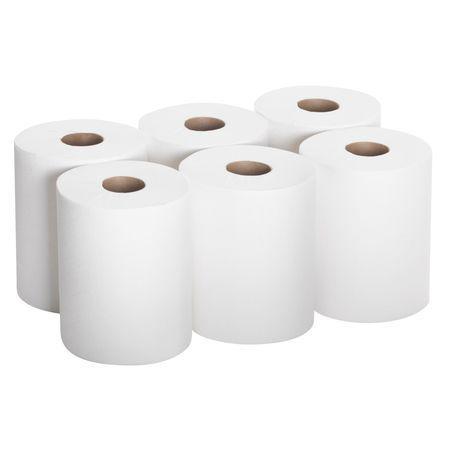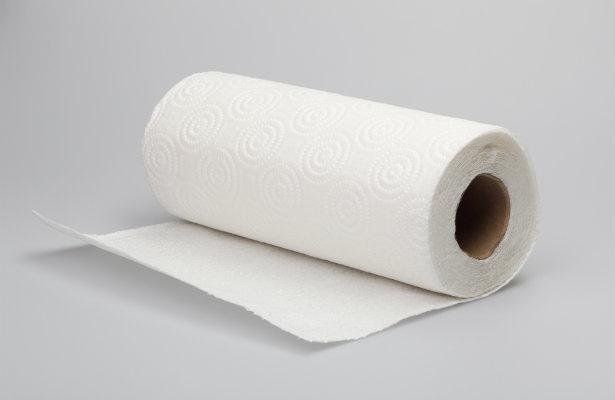The first image is the image on the left, the second image is the image on the right. Considering the images on both sides, is "there are at seven rolls total" valid? Answer yes or no. Yes. 